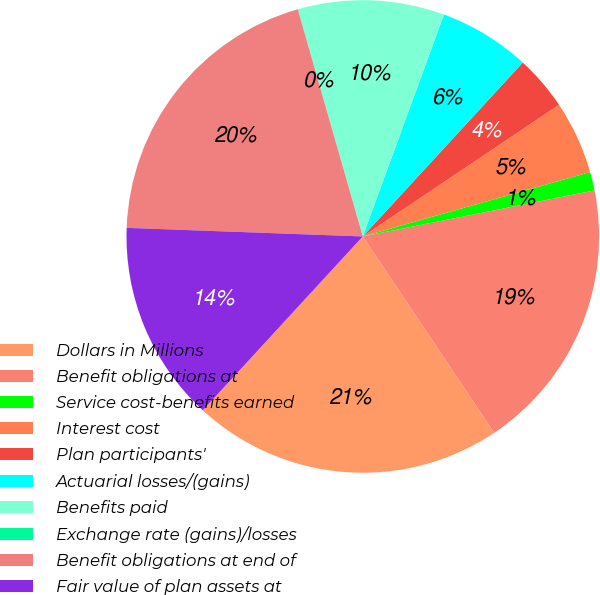<chart> <loc_0><loc_0><loc_500><loc_500><pie_chart><fcel>Dollars in Millions<fcel>Benefit obligations at<fcel>Service cost-benefits earned<fcel>Interest cost<fcel>Plan participants'<fcel>Actuarial losses/(gains)<fcel>Benefits paid<fcel>Exchange rate (gains)/losses<fcel>Benefit obligations at end of<fcel>Fair value of plan assets at<nl><fcel>21.23%<fcel>18.73%<fcel>1.27%<fcel>5.01%<fcel>3.76%<fcel>6.26%<fcel>10.0%<fcel>0.02%<fcel>19.98%<fcel>13.74%<nl></chart> 